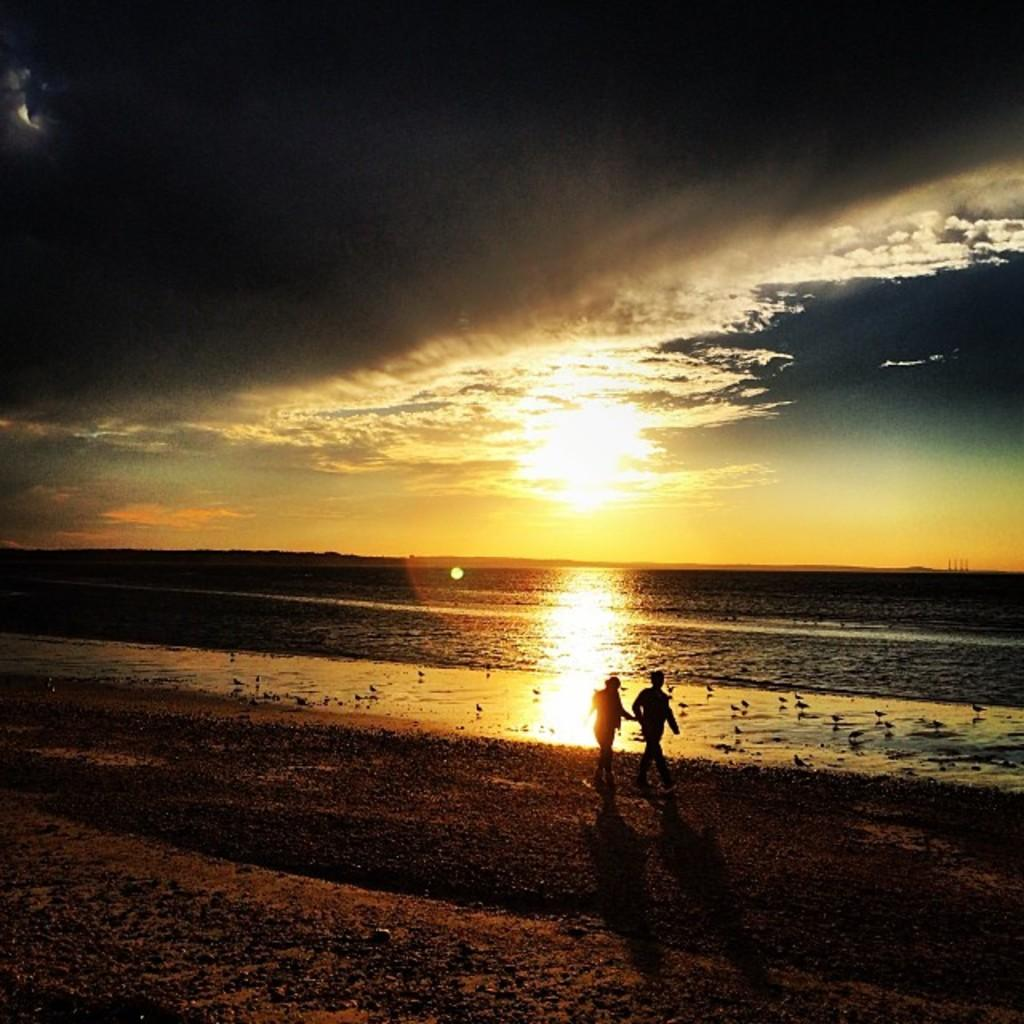How many people are in the image? There are two persons standing in the beach area. What is the main feature in the middle of the image? There is a sea in the middle of the image. What is visible at the top of the image? There is a sky at the top of the image. What thoughts are the girls having while standing in the beach area? There is no mention of girls in the image, and therefore we cannot determine their thoughts. 